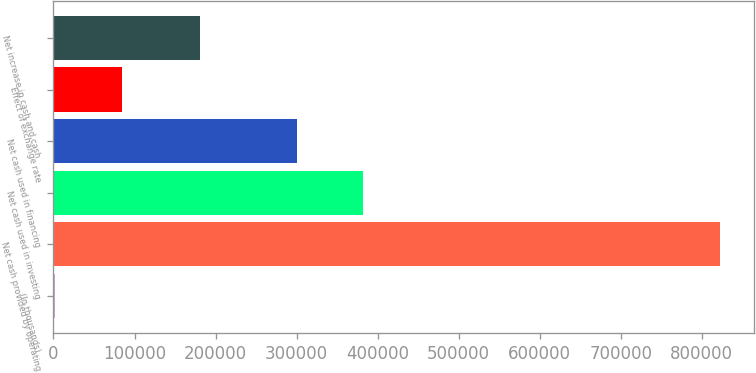<chart> <loc_0><loc_0><loc_500><loc_500><bar_chart><fcel>(In thousands)<fcel>Net cash provided by operating<fcel>Net cash used in investing<fcel>Net cash used in financing<fcel>Effect of exchange rate<fcel>Net increase in cash and cash<nl><fcel>2011<fcel>823166<fcel>382270<fcel>300155<fcel>84126.5<fcel>181411<nl></chart> 